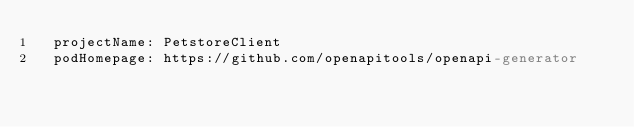<code> <loc_0><loc_0><loc_500><loc_500><_YAML_>  projectName: PetstoreClient
  podHomepage: https://github.com/openapitools/openapi-generator
</code> 